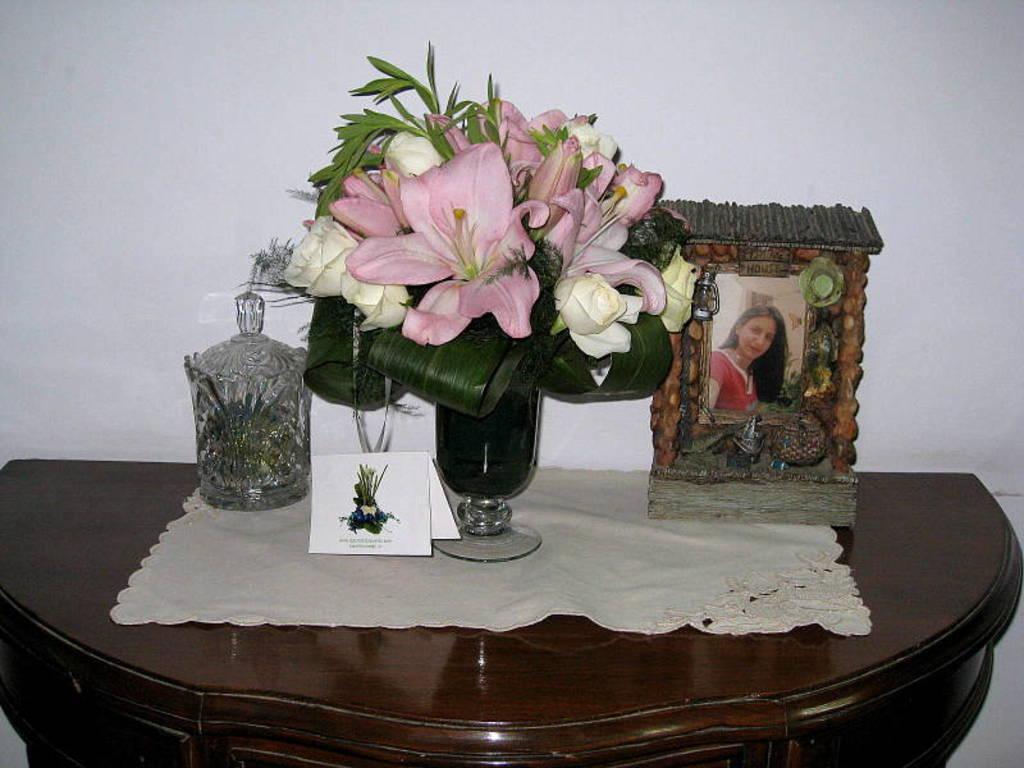How would you summarize this image in a sentence or two? In the picture I can see flower vase, a jar, card, photo frame and the cloth are placed on the wooden table. In the background, I can see the white color wall. 